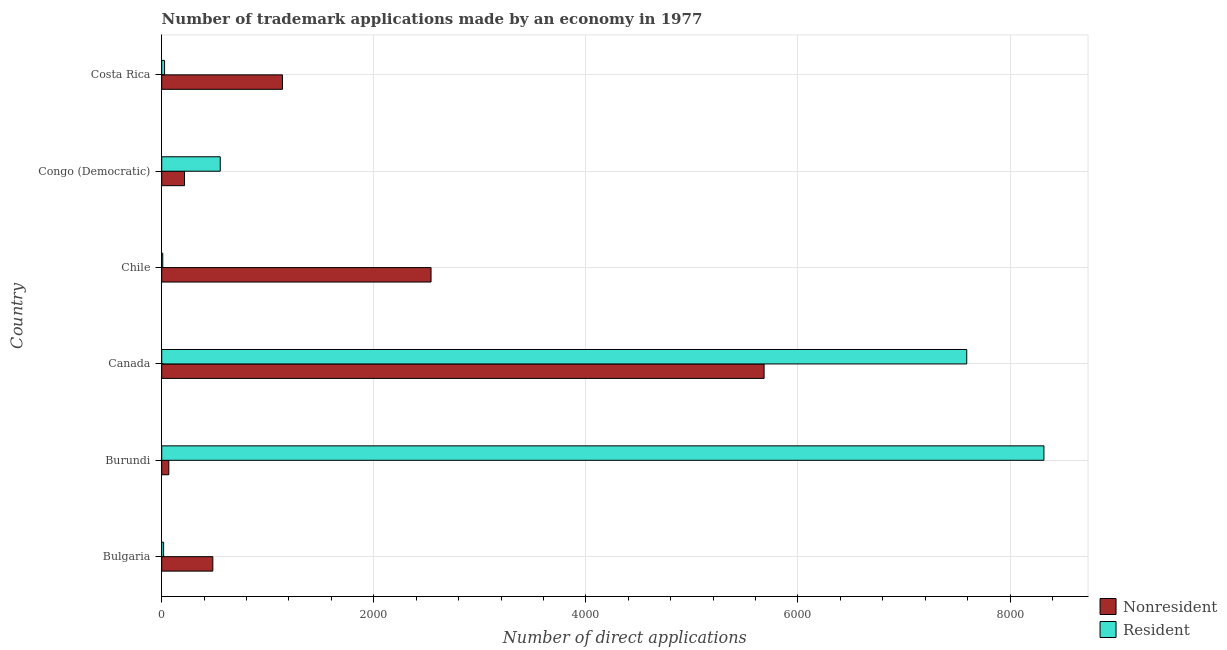How many different coloured bars are there?
Provide a succinct answer. 2. Are the number of bars on each tick of the Y-axis equal?
Offer a terse response. Yes. How many bars are there on the 4th tick from the top?
Offer a terse response. 2. What is the label of the 4th group of bars from the top?
Offer a very short reply. Canada. What is the number of trademark applications made by non residents in Costa Rica?
Your answer should be compact. 1139. Across all countries, what is the maximum number of trademark applications made by residents?
Your answer should be compact. 8320. Across all countries, what is the minimum number of trademark applications made by residents?
Offer a terse response. 10. In which country was the number of trademark applications made by residents maximum?
Your response must be concise. Burundi. What is the total number of trademark applications made by non residents in the graph?
Provide a short and direct response. 1.01e+04. What is the difference between the number of trademark applications made by non residents in Bulgaria and that in Congo (Democratic)?
Provide a succinct answer. 267. What is the difference between the number of trademark applications made by residents in Canada and the number of trademark applications made by non residents in Chile?
Provide a succinct answer. 5052. What is the average number of trademark applications made by residents per country?
Ensure brevity in your answer.  2753.17. What is the difference between the number of trademark applications made by non residents and number of trademark applications made by residents in Costa Rica?
Your answer should be very brief. 1112. What is the ratio of the number of trademark applications made by residents in Burundi to that in Chile?
Offer a terse response. 832. What is the difference between the highest and the second highest number of trademark applications made by residents?
Make the answer very short. 728. What is the difference between the highest and the lowest number of trademark applications made by non residents?
Your answer should be compact. 5614. What does the 1st bar from the top in Costa Rica represents?
Your answer should be compact. Resident. What does the 1st bar from the bottom in Costa Rica represents?
Offer a very short reply. Nonresident. How many bars are there?
Your answer should be compact. 12. How many countries are there in the graph?
Offer a terse response. 6. Does the graph contain any zero values?
Provide a short and direct response. No. Does the graph contain grids?
Provide a short and direct response. Yes. How many legend labels are there?
Offer a very short reply. 2. How are the legend labels stacked?
Ensure brevity in your answer.  Vertical. What is the title of the graph?
Your response must be concise. Number of trademark applications made by an economy in 1977. What is the label or title of the X-axis?
Make the answer very short. Number of direct applications. What is the label or title of the Y-axis?
Give a very brief answer. Country. What is the Number of direct applications in Nonresident in Bulgaria?
Your answer should be very brief. 482. What is the Number of direct applications in Resident in Bulgaria?
Your response must be concise. 18. What is the Number of direct applications of Resident in Burundi?
Your response must be concise. 8320. What is the Number of direct applications of Nonresident in Canada?
Offer a terse response. 5681. What is the Number of direct applications of Resident in Canada?
Your response must be concise. 7592. What is the Number of direct applications of Nonresident in Chile?
Ensure brevity in your answer.  2540. What is the Number of direct applications of Nonresident in Congo (Democratic)?
Your answer should be compact. 215. What is the Number of direct applications of Resident in Congo (Democratic)?
Your response must be concise. 552. What is the Number of direct applications of Nonresident in Costa Rica?
Your response must be concise. 1139. Across all countries, what is the maximum Number of direct applications of Nonresident?
Your response must be concise. 5681. Across all countries, what is the maximum Number of direct applications of Resident?
Offer a very short reply. 8320. Across all countries, what is the minimum Number of direct applications of Nonresident?
Give a very brief answer. 67. Across all countries, what is the minimum Number of direct applications of Resident?
Your answer should be compact. 10. What is the total Number of direct applications in Nonresident in the graph?
Offer a terse response. 1.01e+04. What is the total Number of direct applications in Resident in the graph?
Your answer should be very brief. 1.65e+04. What is the difference between the Number of direct applications of Nonresident in Bulgaria and that in Burundi?
Provide a short and direct response. 415. What is the difference between the Number of direct applications in Resident in Bulgaria and that in Burundi?
Make the answer very short. -8302. What is the difference between the Number of direct applications in Nonresident in Bulgaria and that in Canada?
Your answer should be very brief. -5199. What is the difference between the Number of direct applications of Resident in Bulgaria and that in Canada?
Offer a very short reply. -7574. What is the difference between the Number of direct applications of Nonresident in Bulgaria and that in Chile?
Your answer should be very brief. -2058. What is the difference between the Number of direct applications of Nonresident in Bulgaria and that in Congo (Democratic)?
Offer a very short reply. 267. What is the difference between the Number of direct applications of Resident in Bulgaria and that in Congo (Democratic)?
Your response must be concise. -534. What is the difference between the Number of direct applications in Nonresident in Bulgaria and that in Costa Rica?
Give a very brief answer. -657. What is the difference between the Number of direct applications of Nonresident in Burundi and that in Canada?
Provide a succinct answer. -5614. What is the difference between the Number of direct applications of Resident in Burundi and that in Canada?
Make the answer very short. 728. What is the difference between the Number of direct applications of Nonresident in Burundi and that in Chile?
Your answer should be very brief. -2473. What is the difference between the Number of direct applications in Resident in Burundi and that in Chile?
Make the answer very short. 8310. What is the difference between the Number of direct applications in Nonresident in Burundi and that in Congo (Democratic)?
Your response must be concise. -148. What is the difference between the Number of direct applications in Resident in Burundi and that in Congo (Democratic)?
Your answer should be compact. 7768. What is the difference between the Number of direct applications in Nonresident in Burundi and that in Costa Rica?
Provide a short and direct response. -1072. What is the difference between the Number of direct applications in Resident in Burundi and that in Costa Rica?
Keep it short and to the point. 8293. What is the difference between the Number of direct applications in Nonresident in Canada and that in Chile?
Make the answer very short. 3141. What is the difference between the Number of direct applications of Resident in Canada and that in Chile?
Ensure brevity in your answer.  7582. What is the difference between the Number of direct applications in Nonresident in Canada and that in Congo (Democratic)?
Provide a succinct answer. 5466. What is the difference between the Number of direct applications in Resident in Canada and that in Congo (Democratic)?
Offer a terse response. 7040. What is the difference between the Number of direct applications in Nonresident in Canada and that in Costa Rica?
Offer a terse response. 4542. What is the difference between the Number of direct applications in Resident in Canada and that in Costa Rica?
Offer a very short reply. 7565. What is the difference between the Number of direct applications in Nonresident in Chile and that in Congo (Democratic)?
Make the answer very short. 2325. What is the difference between the Number of direct applications of Resident in Chile and that in Congo (Democratic)?
Your response must be concise. -542. What is the difference between the Number of direct applications of Nonresident in Chile and that in Costa Rica?
Provide a succinct answer. 1401. What is the difference between the Number of direct applications of Nonresident in Congo (Democratic) and that in Costa Rica?
Make the answer very short. -924. What is the difference between the Number of direct applications of Resident in Congo (Democratic) and that in Costa Rica?
Keep it short and to the point. 525. What is the difference between the Number of direct applications of Nonresident in Bulgaria and the Number of direct applications of Resident in Burundi?
Your response must be concise. -7838. What is the difference between the Number of direct applications in Nonresident in Bulgaria and the Number of direct applications in Resident in Canada?
Your response must be concise. -7110. What is the difference between the Number of direct applications in Nonresident in Bulgaria and the Number of direct applications in Resident in Chile?
Offer a terse response. 472. What is the difference between the Number of direct applications in Nonresident in Bulgaria and the Number of direct applications in Resident in Congo (Democratic)?
Keep it short and to the point. -70. What is the difference between the Number of direct applications of Nonresident in Bulgaria and the Number of direct applications of Resident in Costa Rica?
Offer a very short reply. 455. What is the difference between the Number of direct applications of Nonresident in Burundi and the Number of direct applications of Resident in Canada?
Ensure brevity in your answer.  -7525. What is the difference between the Number of direct applications of Nonresident in Burundi and the Number of direct applications of Resident in Congo (Democratic)?
Your answer should be compact. -485. What is the difference between the Number of direct applications of Nonresident in Canada and the Number of direct applications of Resident in Chile?
Make the answer very short. 5671. What is the difference between the Number of direct applications in Nonresident in Canada and the Number of direct applications in Resident in Congo (Democratic)?
Give a very brief answer. 5129. What is the difference between the Number of direct applications of Nonresident in Canada and the Number of direct applications of Resident in Costa Rica?
Offer a very short reply. 5654. What is the difference between the Number of direct applications in Nonresident in Chile and the Number of direct applications in Resident in Congo (Democratic)?
Provide a short and direct response. 1988. What is the difference between the Number of direct applications in Nonresident in Chile and the Number of direct applications in Resident in Costa Rica?
Provide a short and direct response. 2513. What is the difference between the Number of direct applications in Nonresident in Congo (Democratic) and the Number of direct applications in Resident in Costa Rica?
Offer a very short reply. 188. What is the average Number of direct applications in Nonresident per country?
Provide a short and direct response. 1687.33. What is the average Number of direct applications of Resident per country?
Your answer should be very brief. 2753.17. What is the difference between the Number of direct applications of Nonresident and Number of direct applications of Resident in Bulgaria?
Give a very brief answer. 464. What is the difference between the Number of direct applications of Nonresident and Number of direct applications of Resident in Burundi?
Ensure brevity in your answer.  -8253. What is the difference between the Number of direct applications of Nonresident and Number of direct applications of Resident in Canada?
Give a very brief answer. -1911. What is the difference between the Number of direct applications in Nonresident and Number of direct applications in Resident in Chile?
Ensure brevity in your answer.  2530. What is the difference between the Number of direct applications in Nonresident and Number of direct applications in Resident in Congo (Democratic)?
Offer a very short reply. -337. What is the difference between the Number of direct applications in Nonresident and Number of direct applications in Resident in Costa Rica?
Make the answer very short. 1112. What is the ratio of the Number of direct applications of Nonresident in Bulgaria to that in Burundi?
Your answer should be compact. 7.19. What is the ratio of the Number of direct applications of Resident in Bulgaria to that in Burundi?
Give a very brief answer. 0. What is the ratio of the Number of direct applications of Nonresident in Bulgaria to that in Canada?
Keep it short and to the point. 0.08. What is the ratio of the Number of direct applications of Resident in Bulgaria to that in Canada?
Provide a short and direct response. 0. What is the ratio of the Number of direct applications in Nonresident in Bulgaria to that in Chile?
Make the answer very short. 0.19. What is the ratio of the Number of direct applications in Resident in Bulgaria to that in Chile?
Ensure brevity in your answer.  1.8. What is the ratio of the Number of direct applications of Nonresident in Bulgaria to that in Congo (Democratic)?
Your response must be concise. 2.24. What is the ratio of the Number of direct applications in Resident in Bulgaria to that in Congo (Democratic)?
Make the answer very short. 0.03. What is the ratio of the Number of direct applications in Nonresident in Bulgaria to that in Costa Rica?
Offer a terse response. 0.42. What is the ratio of the Number of direct applications in Nonresident in Burundi to that in Canada?
Give a very brief answer. 0.01. What is the ratio of the Number of direct applications in Resident in Burundi to that in Canada?
Keep it short and to the point. 1.1. What is the ratio of the Number of direct applications of Nonresident in Burundi to that in Chile?
Give a very brief answer. 0.03. What is the ratio of the Number of direct applications in Resident in Burundi to that in Chile?
Make the answer very short. 832. What is the ratio of the Number of direct applications in Nonresident in Burundi to that in Congo (Democratic)?
Keep it short and to the point. 0.31. What is the ratio of the Number of direct applications of Resident in Burundi to that in Congo (Democratic)?
Offer a terse response. 15.07. What is the ratio of the Number of direct applications in Nonresident in Burundi to that in Costa Rica?
Your response must be concise. 0.06. What is the ratio of the Number of direct applications of Resident in Burundi to that in Costa Rica?
Offer a very short reply. 308.15. What is the ratio of the Number of direct applications in Nonresident in Canada to that in Chile?
Your answer should be very brief. 2.24. What is the ratio of the Number of direct applications of Resident in Canada to that in Chile?
Ensure brevity in your answer.  759.2. What is the ratio of the Number of direct applications of Nonresident in Canada to that in Congo (Democratic)?
Your answer should be very brief. 26.42. What is the ratio of the Number of direct applications of Resident in Canada to that in Congo (Democratic)?
Provide a succinct answer. 13.75. What is the ratio of the Number of direct applications in Nonresident in Canada to that in Costa Rica?
Keep it short and to the point. 4.99. What is the ratio of the Number of direct applications of Resident in Canada to that in Costa Rica?
Give a very brief answer. 281.19. What is the ratio of the Number of direct applications in Nonresident in Chile to that in Congo (Democratic)?
Provide a short and direct response. 11.81. What is the ratio of the Number of direct applications of Resident in Chile to that in Congo (Democratic)?
Ensure brevity in your answer.  0.02. What is the ratio of the Number of direct applications of Nonresident in Chile to that in Costa Rica?
Make the answer very short. 2.23. What is the ratio of the Number of direct applications of Resident in Chile to that in Costa Rica?
Offer a very short reply. 0.37. What is the ratio of the Number of direct applications in Nonresident in Congo (Democratic) to that in Costa Rica?
Your response must be concise. 0.19. What is the ratio of the Number of direct applications in Resident in Congo (Democratic) to that in Costa Rica?
Provide a short and direct response. 20.44. What is the difference between the highest and the second highest Number of direct applications in Nonresident?
Your answer should be very brief. 3141. What is the difference between the highest and the second highest Number of direct applications of Resident?
Your answer should be very brief. 728. What is the difference between the highest and the lowest Number of direct applications in Nonresident?
Make the answer very short. 5614. What is the difference between the highest and the lowest Number of direct applications in Resident?
Your answer should be compact. 8310. 